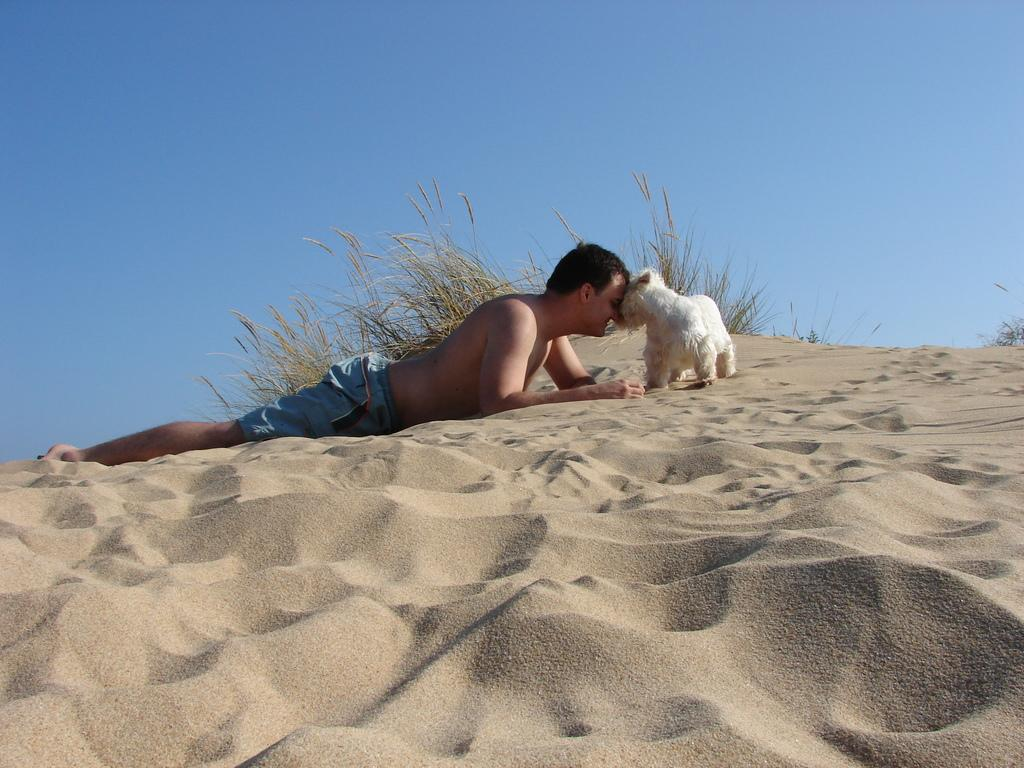What is the setting of the image? The image is taken in a desert. What is the man in the image doing? The man is lying on the sand and playing with a dog. What can be seen in the background of the image? There are trees and the sky visible in the background of the image. What type of joke is the man telling the dog in the image? There is no indication in the image that the man is telling a joke to the dog. The man is simply playing with the dog. What type of floor can be seen in the image? There is no floor visible in the image, as it is taken in a desert where the ground is covered with sand. 